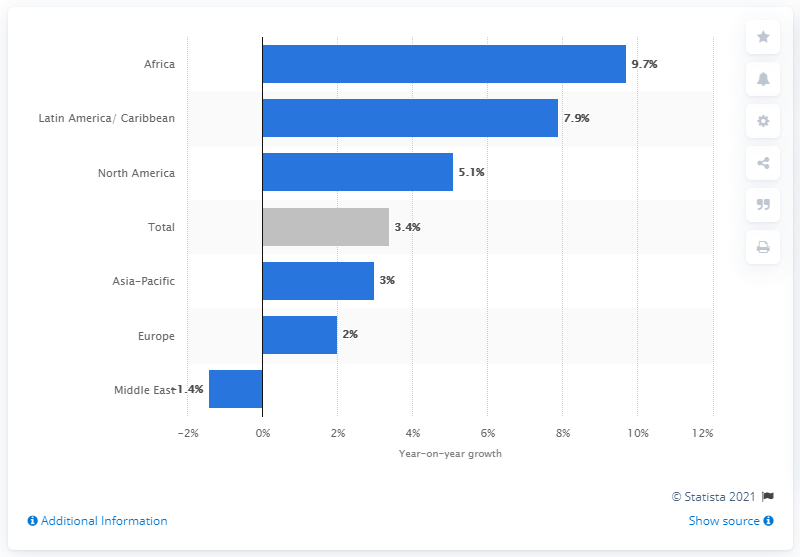List a handful of essential elements in this visual. In 2018, cargo traffic at North American airports increased by 5.1% compared to the previous year. 